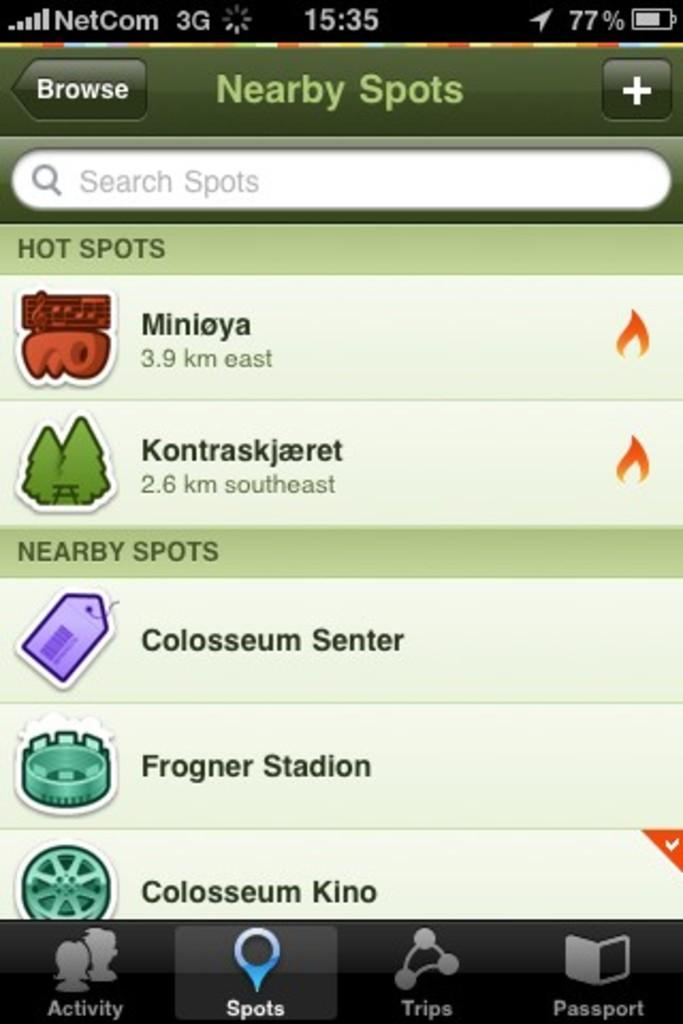What is the main object in the image? There is a screen in the image. What can be seen on the screen? Symbols and text are visible on the screen. What type of advice can be seen on the screen in the image? There is no advice visible on the screen in the image; the image only shows symbols and text. 